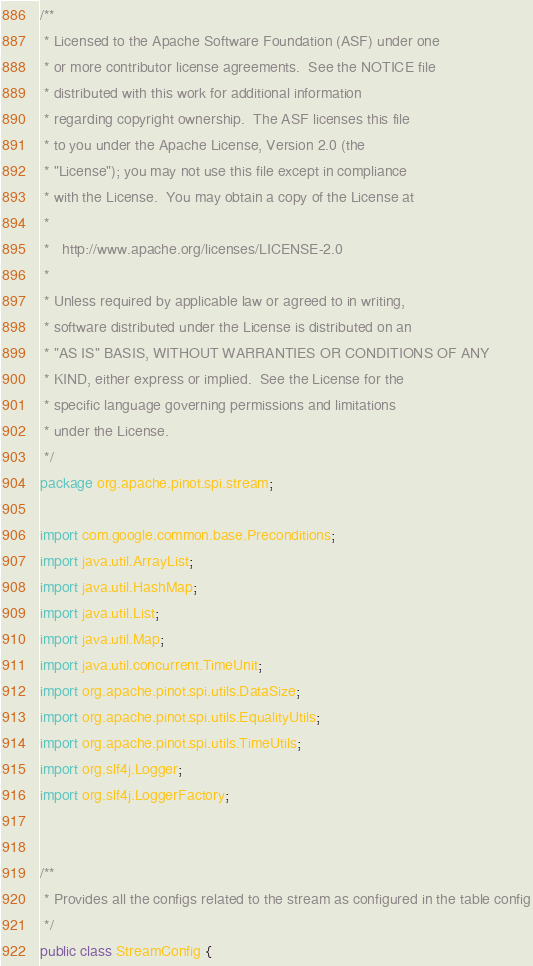<code> <loc_0><loc_0><loc_500><loc_500><_Java_>/**
 * Licensed to the Apache Software Foundation (ASF) under one
 * or more contributor license agreements.  See the NOTICE file
 * distributed with this work for additional information
 * regarding copyright ownership.  The ASF licenses this file
 * to you under the Apache License, Version 2.0 (the
 * "License"); you may not use this file except in compliance
 * with the License.  You may obtain a copy of the License at
 *
 *   http://www.apache.org/licenses/LICENSE-2.0
 *
 * Unless required by applicable law or agreed to in writing,
 * software distributed under the License is distributed on an
 * "AS IS" BASIS, WITHOUT WARRANTIES OR CONDITIONS OF ANY
 * KIND, either express or implied.  See the License for the
 * specific language governing permissions and limitations
 * under the License.
 */
package org.apache.pinot.spi.stream;

import com.google.common.base.Preconditions;
import java.util.ArrayList;
import java.util.HashMap;
import java.util.List;
import java.util.Map;
import java.util.concurrent.TimeUnit;
import org.apache.pinot.spi.utils.DataSize;
import org.apache.pinot.spi.utils.EqualityUtils;
import org.apache.pinot.spi.utils.TimeUtils;
import org.slf4j.Logger;
import org.slf4j.LoggerFactory;


/**
 * Provides all the configs related to the stream as configured in the table config
 */
public class StreamConfig {</code> 